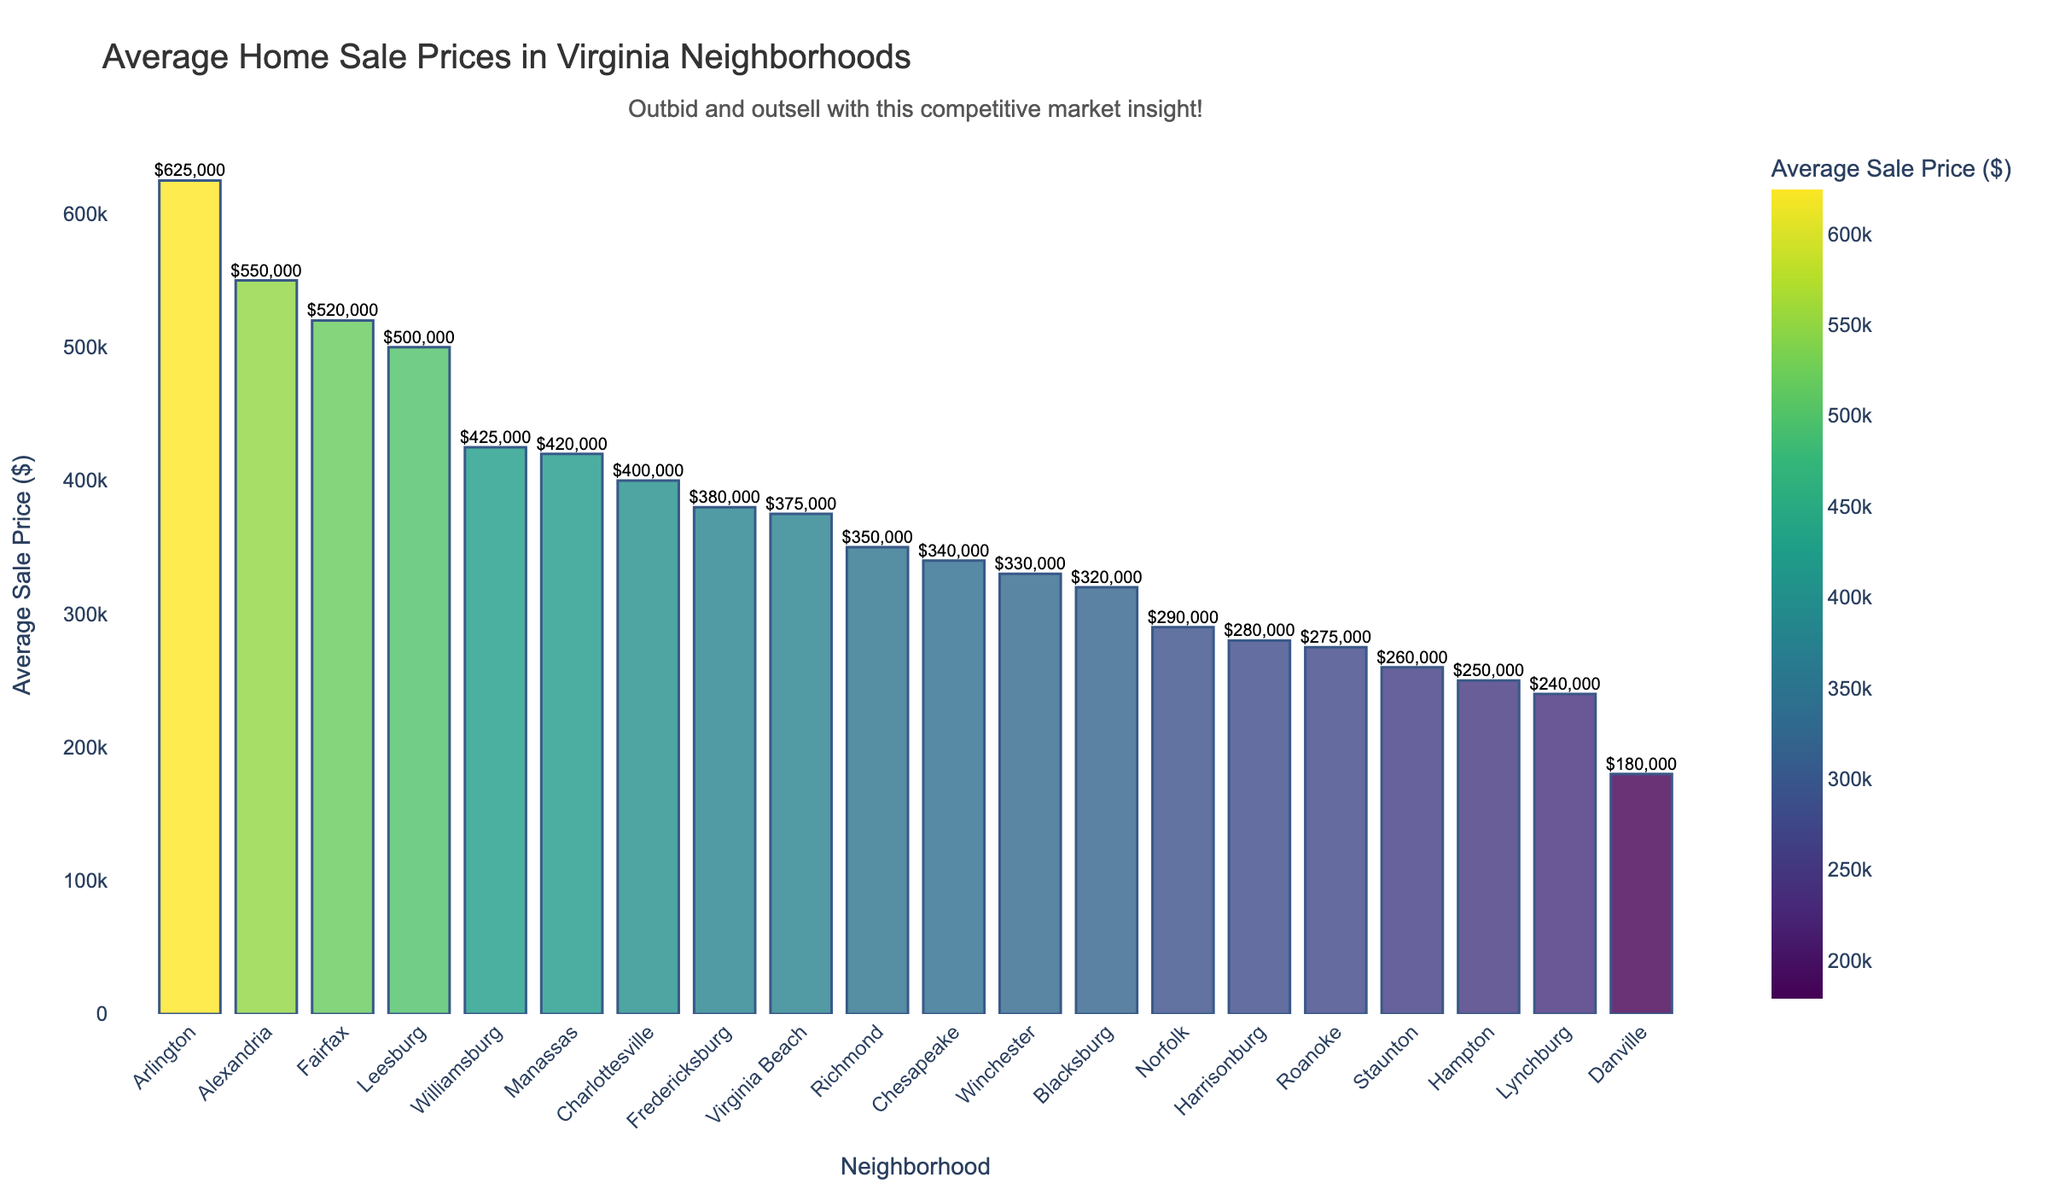What is the neighborhood with the highest average sale price? Identify the tallest bar in the chart, which represents the highest average sale price. The label at the base of this bar corresponds to the neighborhood.
Answer: Arlington Which neighborhood has a higher average sale price, Alexandria or Virginia Beach? Compare the heights of the bars for Alexandria and Virginia Beach. The taller bar indicates the neighborhood with the higher average sale price.
Answer: Alexandria What is the difference in average sale price between Richmond and Roanoke? Locate the bars for Richmond and Roanoke. Subtract the value for Roanoke from the value for Richmond.
Answer: $75,000 How many neighborhoods have an average sale price above $400,000? Count the bars that exceed the $400,000 mark.
Answer: 5 Which neighborhood has the second lowest average sale price? Identify the two shortest bars. The second shortest bar represents the neighborhood with the second lowest average sale price.
Answer: Staunton What is the total average sale price of the top three most expensive neighborhoods? Identify the top three neighborhoods by their bar heights and sum their average sale prices. Arlington ($625,000) + Alexandria ($550,000) + Leesburg ($500,000)
Answer: $1,675,000 Which neighborhood has an average sale price closest to $300,000? Identify the bar whose height is nearest to the $300,000 mark.
Answer: Norfolk What is the average sale price of neighborhoods with names starting with "W"? Extract the values for Williamsburg and Winchester and calculate their average. (425,000 + 330,000) / 2
Answer: $377,500 How much more expensive is Fairfax compared to Lynchburg? Subtract the value for Lynchburg from the value for Fairfax.
Answer: $280,000 Are there more neighborhoods with an average sale price above or below $400,000? Count the bars above and below the $400,000 mark, respectively, to determine which has more.
Answer: Below 